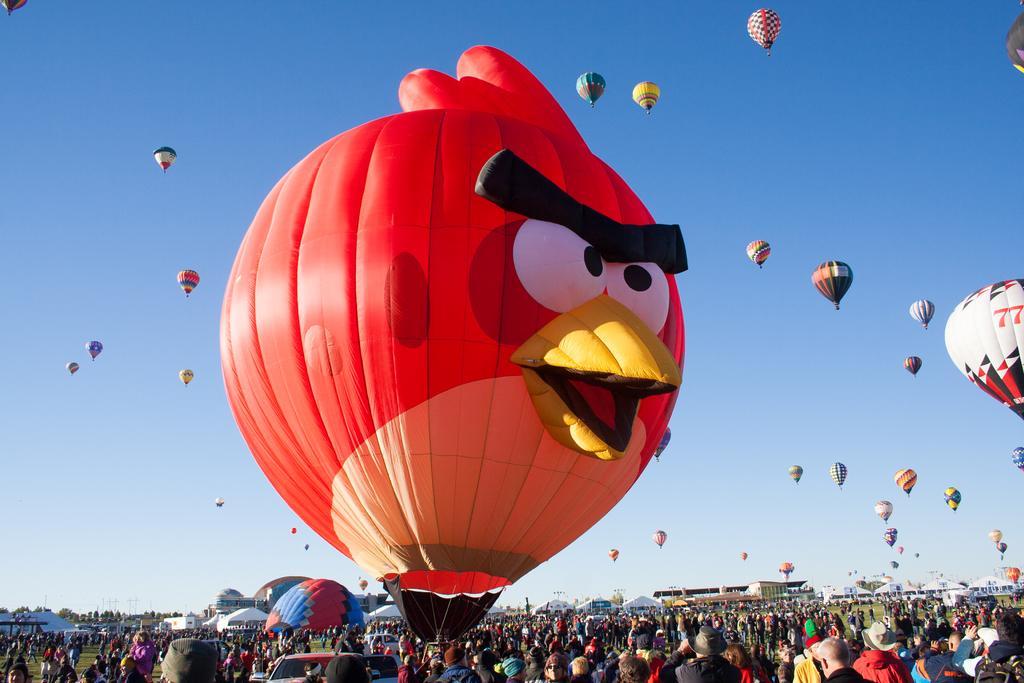Could you give a brief overview of what you see in this image? In this picture there are few people standing on a greenery ground and there are few gas balloons were one among them is in the shape of angry bird is in the sky. 